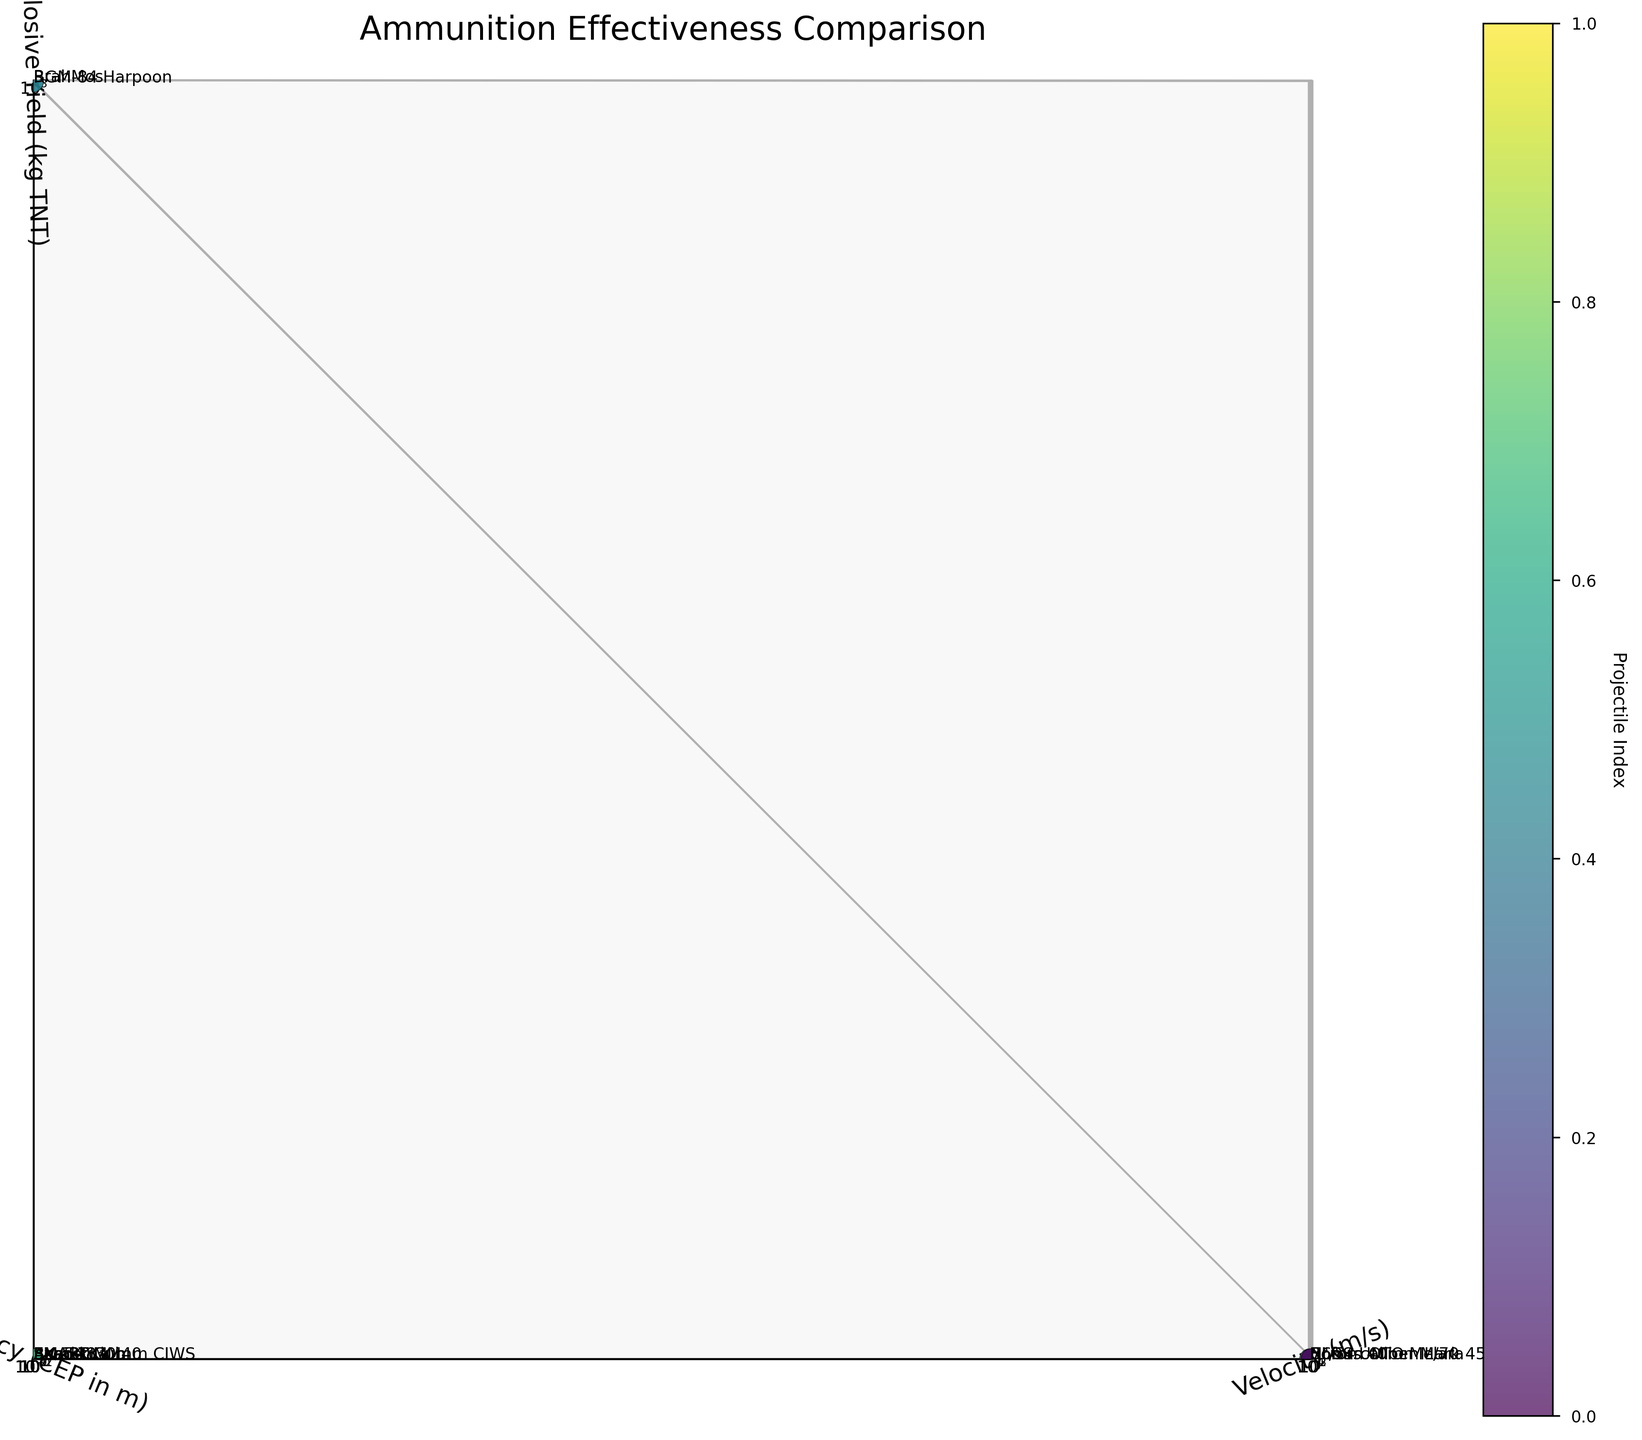What is the title of the figure? The title of the figure should be present at the top, and it is usually in a larger font size. Here, the title is "Ammunition Effectiveness Comparison".
Answer: Ammunition Effectiveness Comparison Which axis represents Accuracy (CEP in m)? In a 3D scatter plot, the labels of the axes help identify which attribute each axis represents. Here, the y-axis represents Accuracy (CEP in m).
Answer: y-axis How many data points are there in the plot? Count the number of projectiles listed in the data table provided. There are a total of 12 projectiles.
Answer: 12 Which projectile has the highest explosive yield? Find the projectile with the highest value on the z-axis, which represents the explosive yield. The BrahMos, with 300 kg TNT, has the highest explosive yield.
Answer: BrahMos What is the explosive yield of the projectile with the highest velocity? Identify the projectile with the highest value on the x-axis, which is the BrahMos with a velocity of 3000 m/s. Its explosive yield is shown on the z-axis as 300 kg TNT.
Answer: 300 kg TNT Which projectile has the best accuracy (lowest CEP)? Look for the data point with the lowest value on the y-axis, representing the most accurate projectile. The Exocet MM40 has the lowest CEP of 1 meter.
Answer: Exocet MM40 Compare the velocities and explosive yields of the 76mm OTO Melara and NLOS-UM. Which has higher values for each attribute? Identify the data points for both projectiles. The 76mm OTO Melara has a velocity of 925 m/s and an explosive yield of 0.7 kg TNT. NLOS-UM has a velocity of 300 m/s and an explosive yield of 15 kg TNT. The 76mm OTO Melara has higher velocity, while the NLOS-UM has a higher explosive yield.
Answer: 76mm OTO Melara has higher velocity, NLOS-UM has higher explosive yield Which projectile is the most balanced in terms of having moderate values for all three attributes? Look for a data point that is central in the x, y, and z dimensions without any extreme highs or lows. The SMART projectile with values (500 m/s, 2 m CEP, 8 kg TNT) is moderately balanced across all three attributes.
Answer: SMART What is the ratio of accuracy between the Barak-8 and the 3M-54 Klub? Identify the Accuracy values for Barak-8 (0.5 m) and 3M-54 Klub (2 m). The ratio of accuracy is 0.5 to 2, which simplifies to 1:4. This indicates that the Barak-8 is four times more accurate than the 3M-54 Klub.
Answer: 1:4 Which projectile would be considered the least effective based on explosive yield alone? Find the projectile with the lowest value on the z-axis. The AK-630 30mm CIWS has the lowest explosive yield with 0.1 kg TNT.
Answer: AK-630 30mm CIWS 